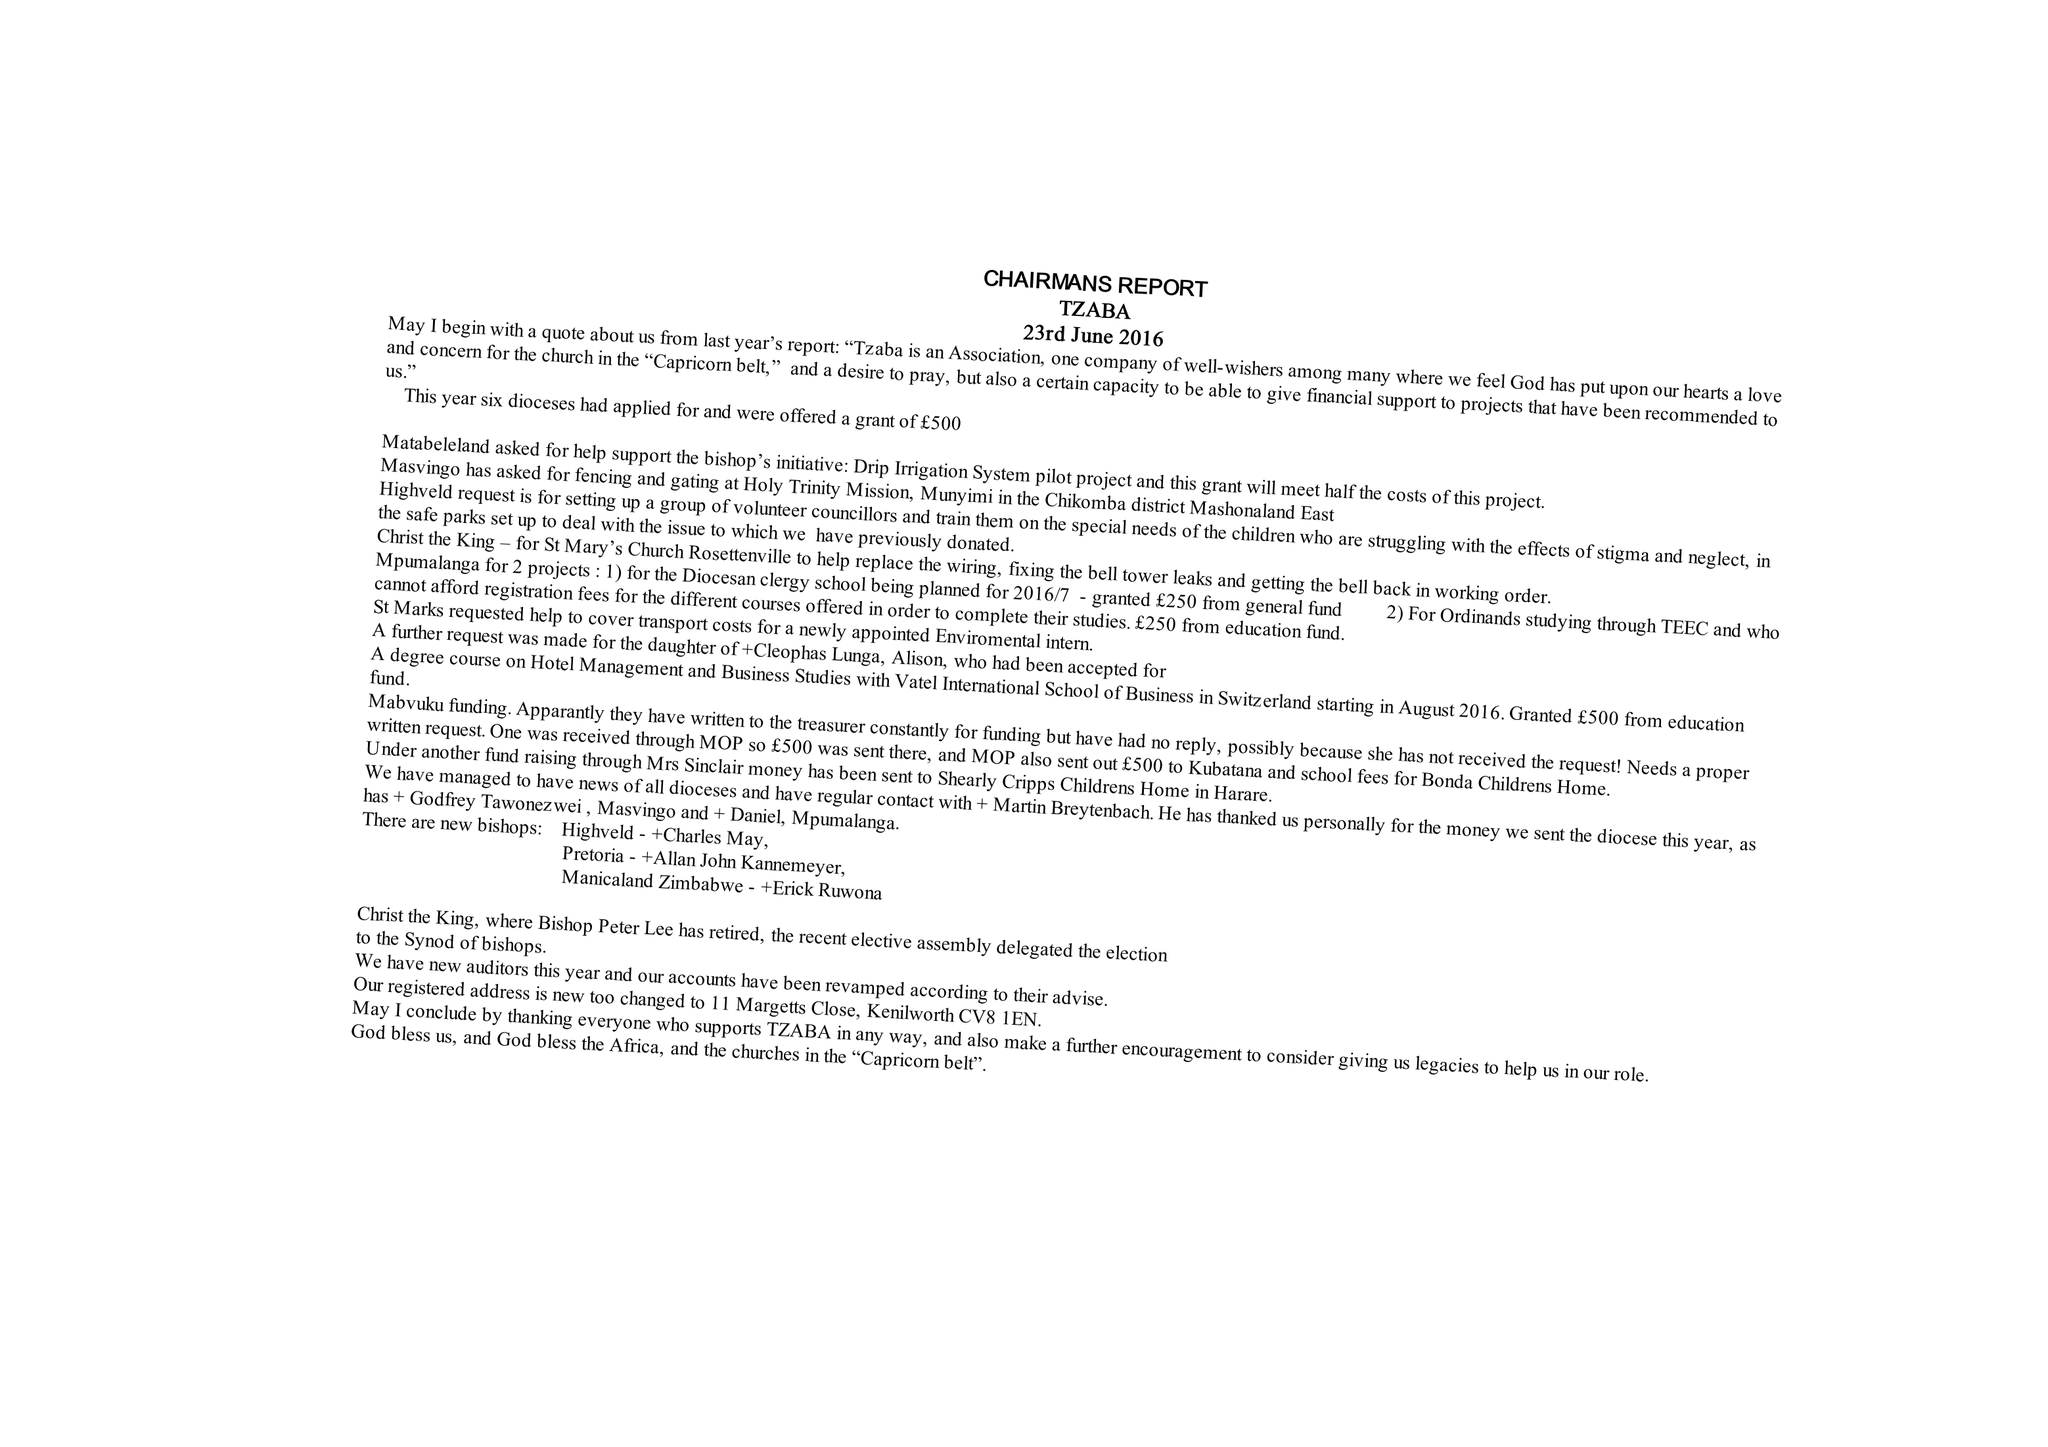What is the value for the income_annually_in_british_pounds?
Answer the question using a single word or phrase. 27362.00 